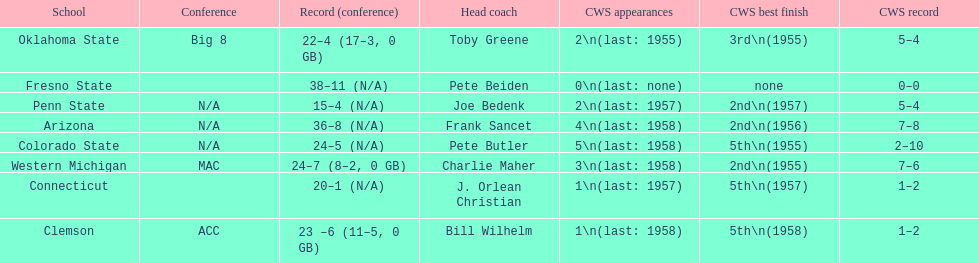What are the teams in the conference? Arizona, Clemson, Colorado State, Connecticut, Fresno State, Oklahoma State, Penn State, Western Michigan. Which have more than 16 wins? Arizona, Clemson, Colorado State, Connecticut, Fresno State, Oklahoma State, Western Michigan. Which had less than 16 wins? Penn State. 